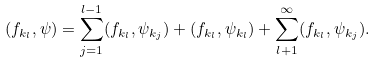<formula> <loc_0><loc_0><loc_500><loc_500>( f _ { k _ { l } } , \psi ) = \sum _ { j = 1 } ^ { l - 1 } ( f _ { k _ { l } } , \psi _ { k _ { j } } ) + ( f _ { k _ { l } } , \psi _ { k _ { l } } ) + \sum _ { l + 1 } ^ { \infty } ( f _ { k _ { l } } , \psi _ { k _ { j } } ) .</formula> 